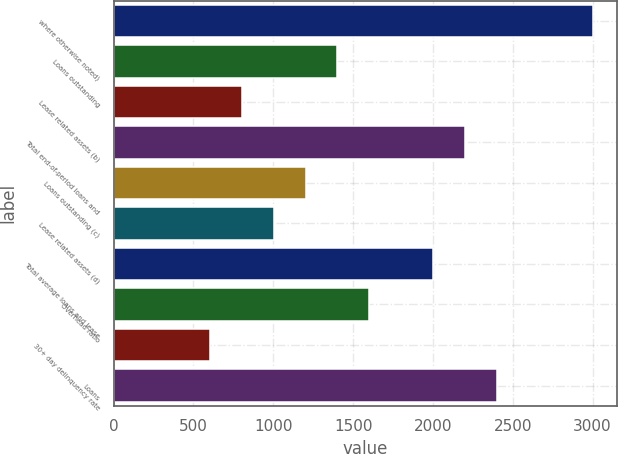Convert chart to OTSL. <chart><loc_0><loc_0><loc_500><loc_500><bar_chart><fcel>where otherwise noted)<fcel>Loans outstanding<fcel>Lease related assets (b)<fcel>Total end-of-period loans and<fcel>Loans outstanding (c)<fcel>Lease related assets (d)<fcel>Total average loans and lease<fcel>Overhead ratio<fcel>30+ day delinquency rate<fcel>Loans<nl><fcel>3004.32<fcel>1402.24<fcel>801.46<fcel>2203.28<fcel>1201.98<fcel>1001.72<fcel>2003.02<fcel>1602.5<fcel>601.2<fcel>2403.54<nl></chart> 